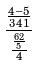Convert formula to latex. <formula><loc_0><loc_0><loc_500><loc_500>\frac { \frac { 4 - 5 } { 3 4 1 } } { \frac { \frac { 6 2 } { 5 } } { 4 } }</formula> 